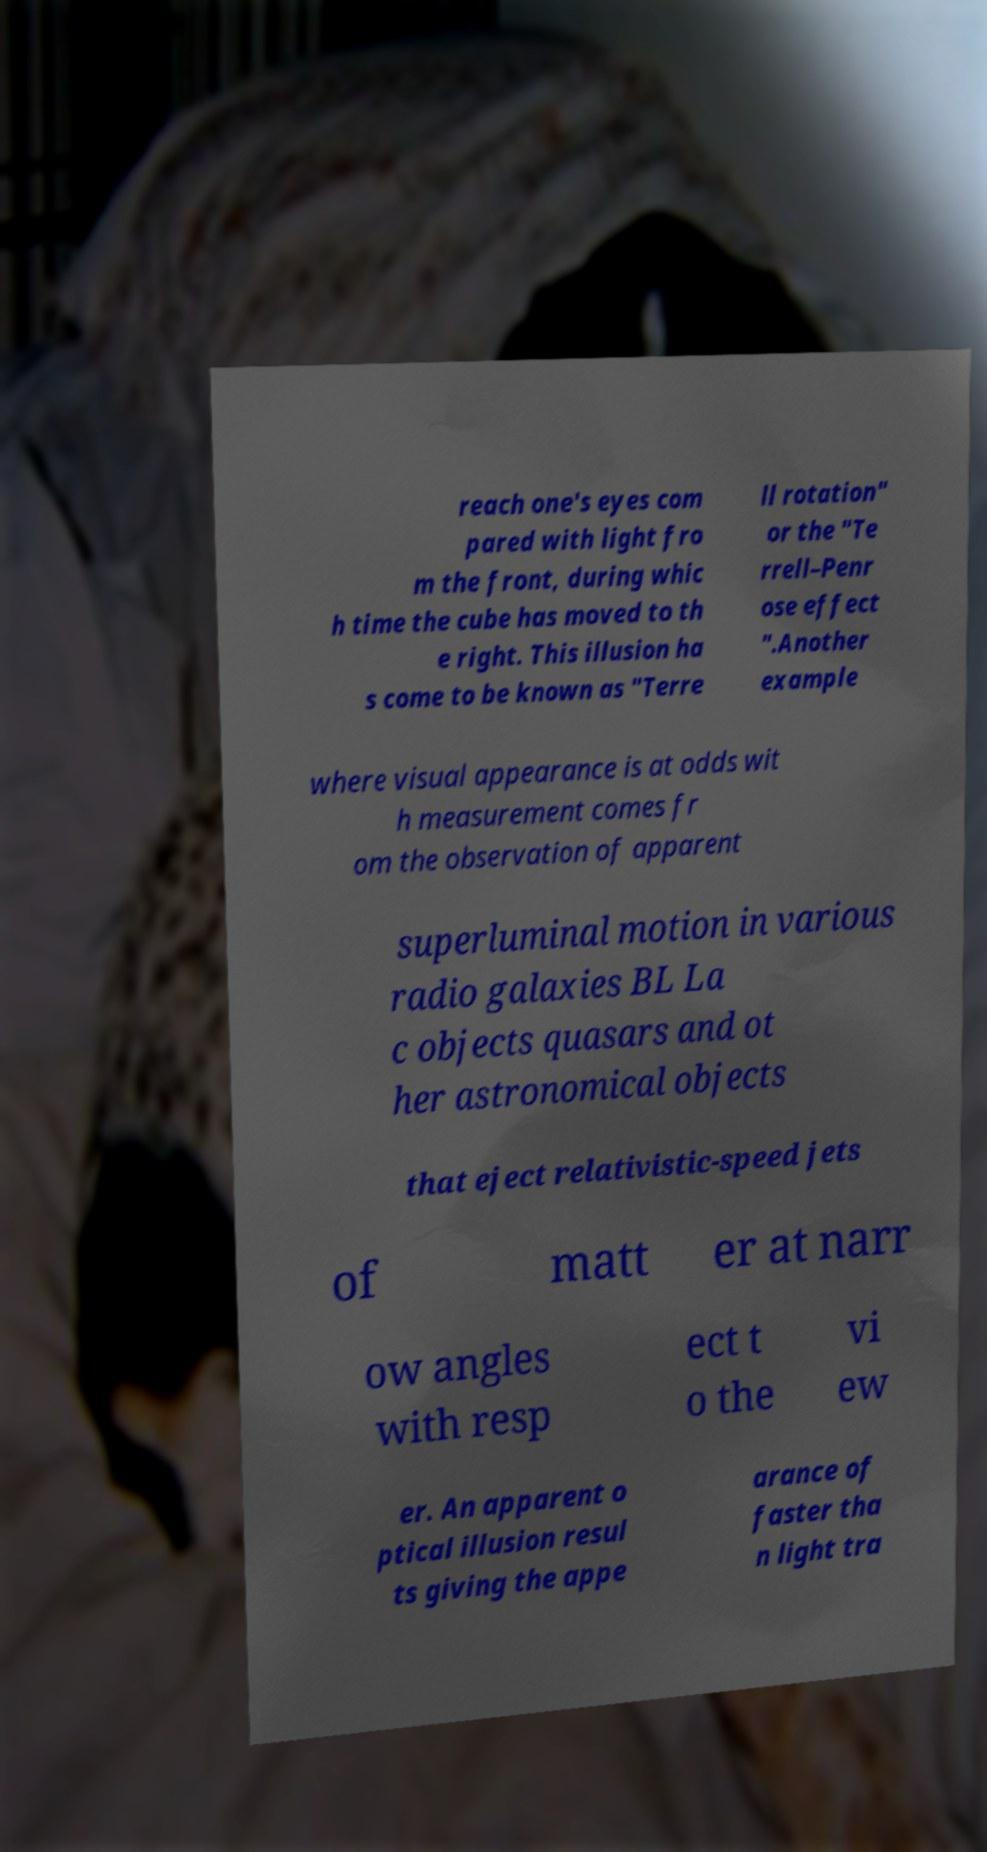I need the written content from this picture converted into text. Can you do that? reach one's eyes com pared with light fro m the front, during whic h time the cube has moved to th e right. This illusion ha s come to be known as "Terre ll rotation" or the "Te rrell–Penr ose effect ".Another example where visual appearance is at odds wit h measurement comes fr om the observation of apparent superluminal motion in various radio galaxies BL La c objects quasars and ot her astronomical objects that eject relativistic-speed jets of matt er at narr ow angles with resp ect t o the vi ew er. An apparent o ptical illusion resul ts giving the appe arance of faster tha n light tra 